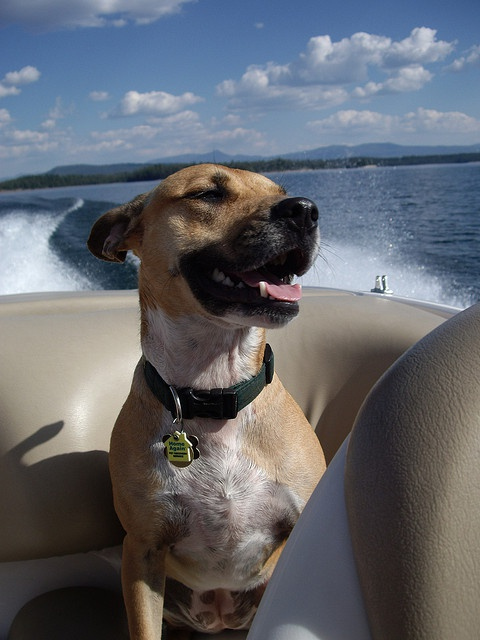Describe the objects in this image and their specific colors. I can see boat in gray, black, and darkgray tones and dog in gray, black, and darkgray tones in this image. 